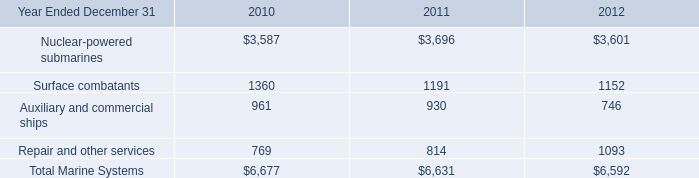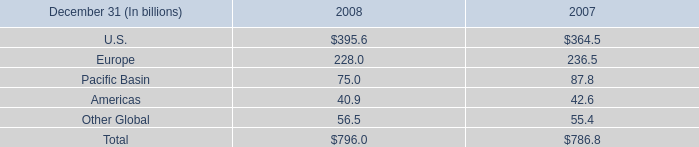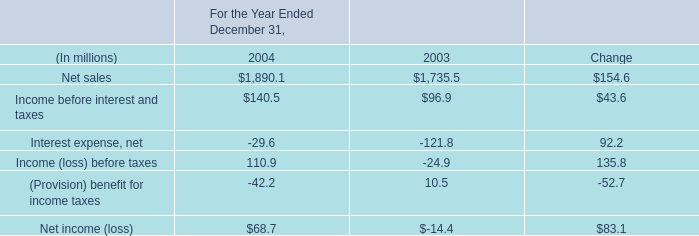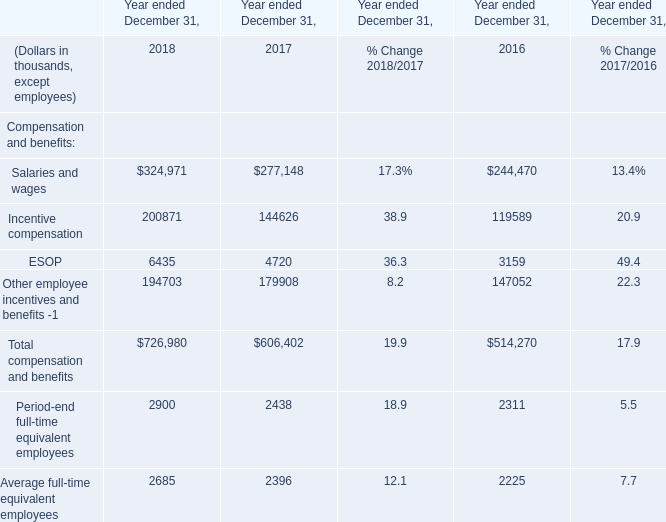What is the average amount of Incentive compensation of Year ended December 31, 2017, and Net sales of For the Year Ended December 31, 2004 ? 
Computations: ((144626.0 + 1890.1) / 2)
Answer: 73258.05. 